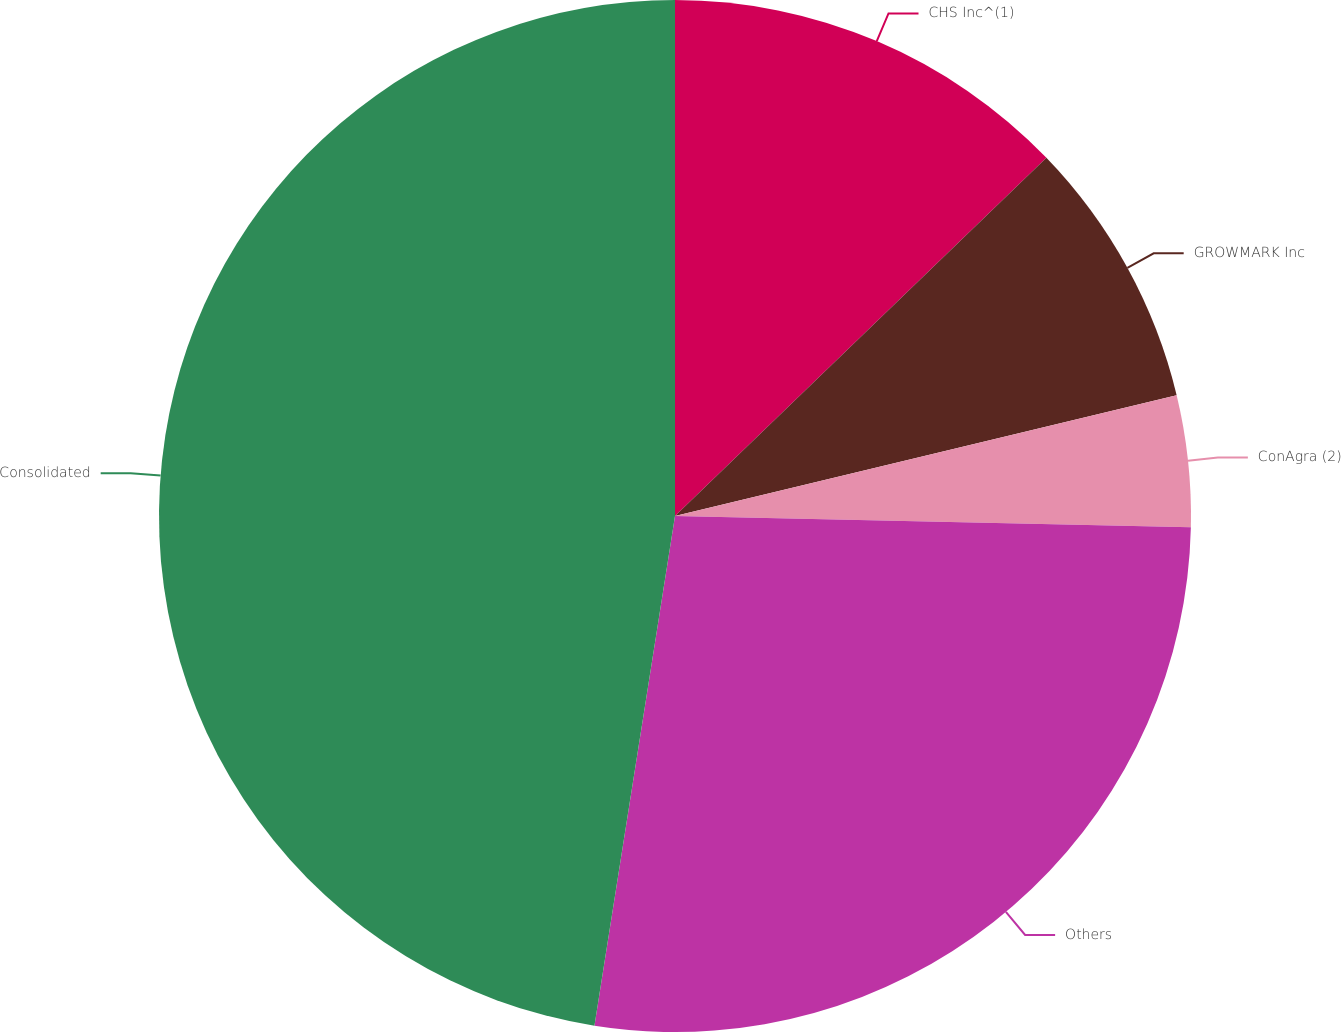Convert chart to OTSL. <chart><loc_0><loc_0><loc_500><loc_500><pie_chart><fcel>CHS Inc^(1)<fcel>GROWMARK Inc<fcel>ConAgra (2)<fcel>Others<fcel>Consolidated<nl><fcel>12.79%<fcel>8.45%<fcel>4.11%<fcel>27.15%<fcel>47.51%<nl></chart> 